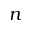<formula> <loc_0><loc_0><loc_500><loc_500>n</formula> 